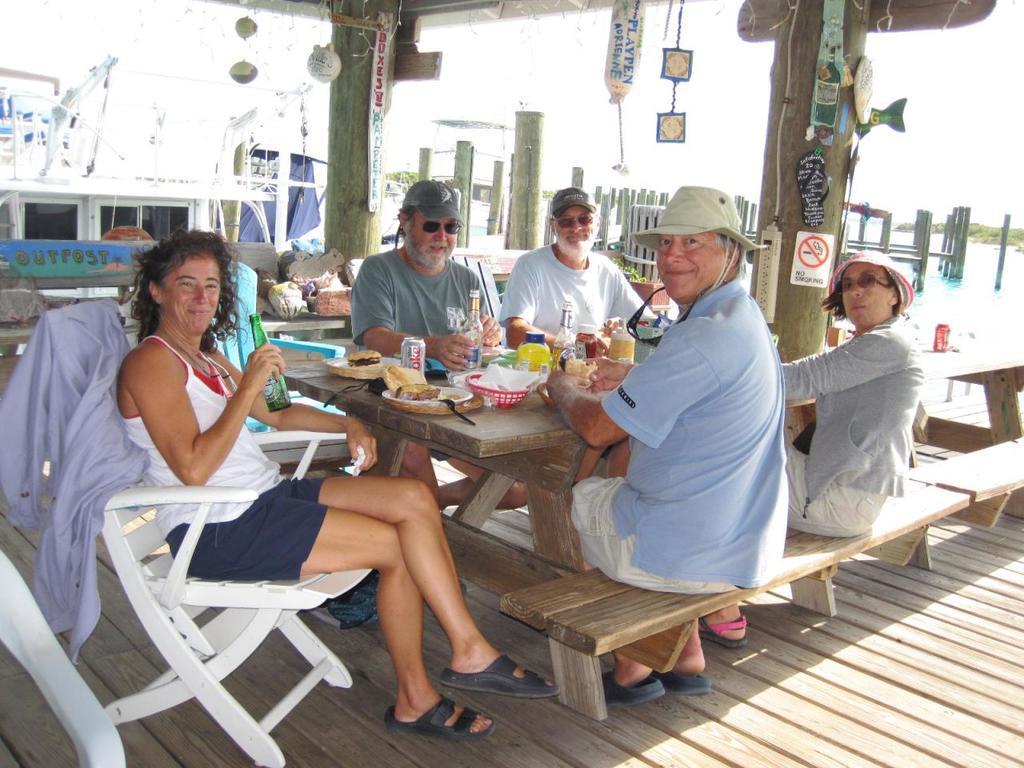Describe this image in one or two sentences. This picture is of outside. On the right we can see group of persons sitting on the bench and there is a table on the top of which food items are placed. On the left there is a woman wearing a white color t-shirt, smiling, holding a bottle and sitting on the chair. In the background we can see the sky, water body, a building. 